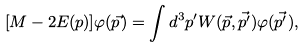<formula> <loc_0><loc_0><loc_500><loc_500>[ M - 2 E ( p ) ] \varphi ( \vec { p } ) = \int d ^ { 3 } p ^ { \prime } W ( \vec { p } , \vec { p ^ { \prime } } ) \varphi ( \vec { p ^ { \prime } } ) ,</formula> 